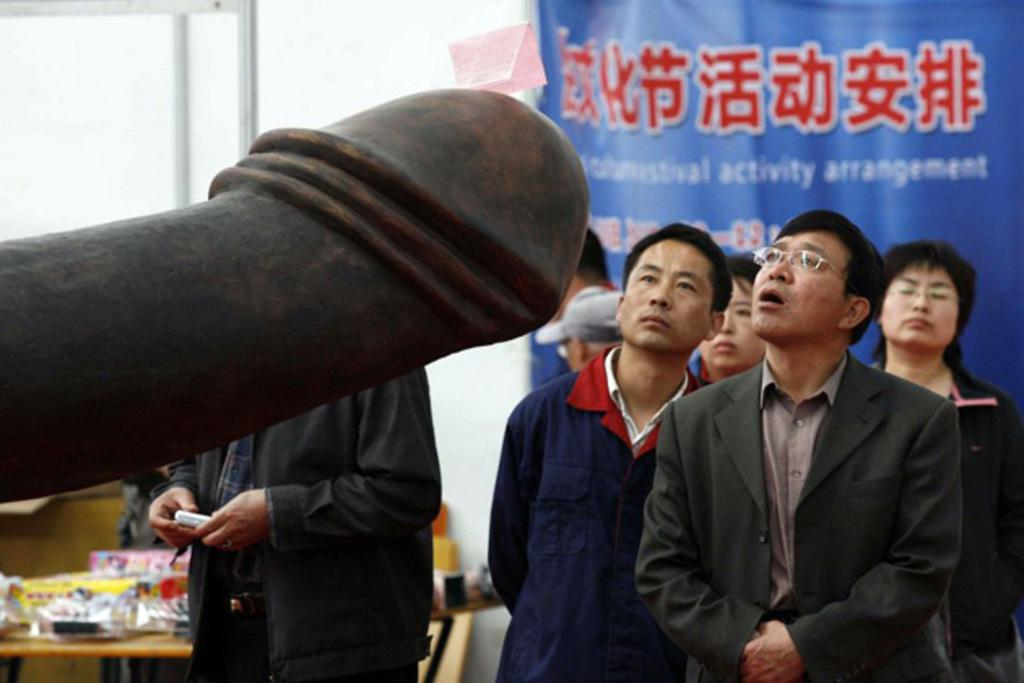How many people are in the image? There are persons standing in the image. What is the surface on which the persons are standing? The persons are standing on the floor. What can be seen on the table in the image? There are objects placed on a table in the image. What is displayed on the wall in the image? There is an advertisement on a wall in the image. What color is the bat flying in the image? There is no bat present in the image. How many eyes does the person on the left have in the image? The image does not show the number of eyes the person has; it only shows their silhouette. 